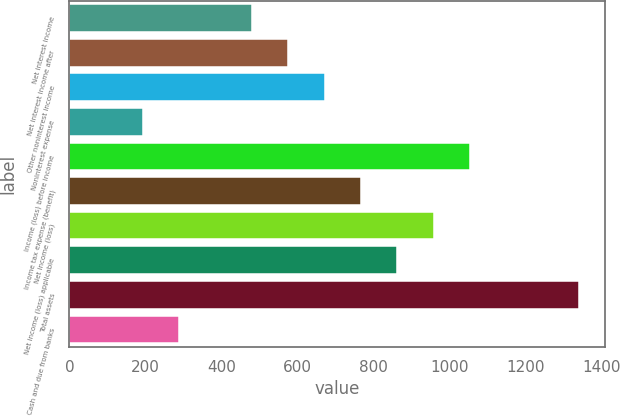Convert chart. <chart><loc_0><loc_0><loc_500><loc_500><bar_chart><fcel>Net interest income<fcel>Net interest income after<fcel>Other noninterest income<fcel>Noninterest expense<fcel>Income (loss) before income<fcel>Income tax expense (benefit)<fcel>Net income (loss)<fcel>Net income (loss) applicable<fcel>Total assets<fcel>Cash and due from banks<nl><fcel>480.5<fcel>576.2<fcel>671.9<fcel>193.4<fcel>1054.7<fcel>767.6<fcel>959<fcel>863.3<fcel>1341.8<fcel>289.1<nl></chart> 